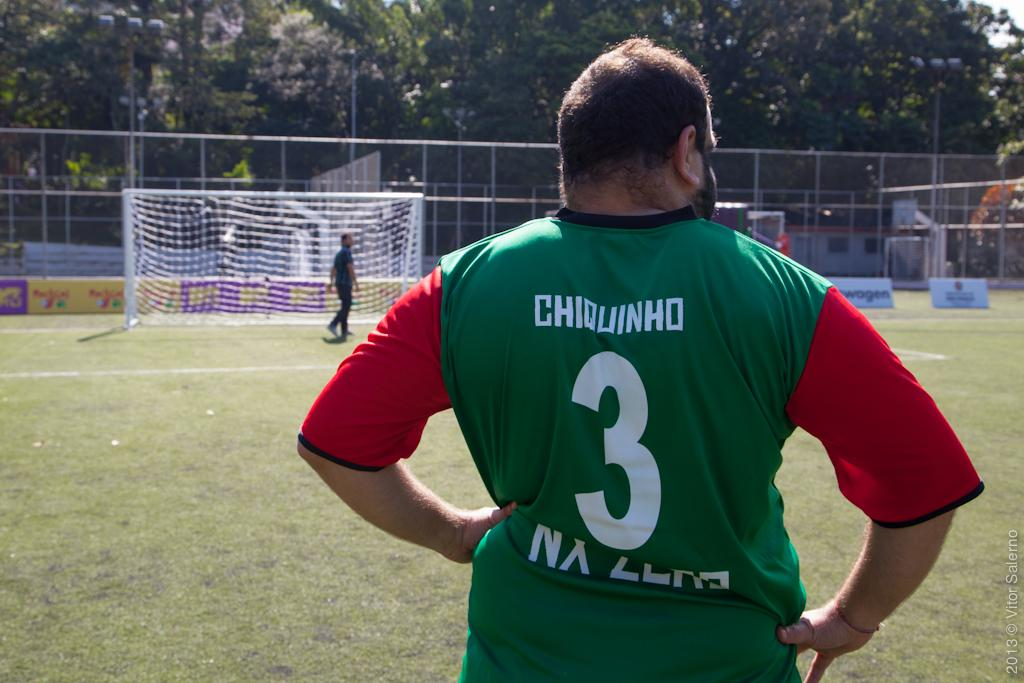<image>
Describe the image concisely. A soccer player stands on the field his jersey says Chiquinho number 3 